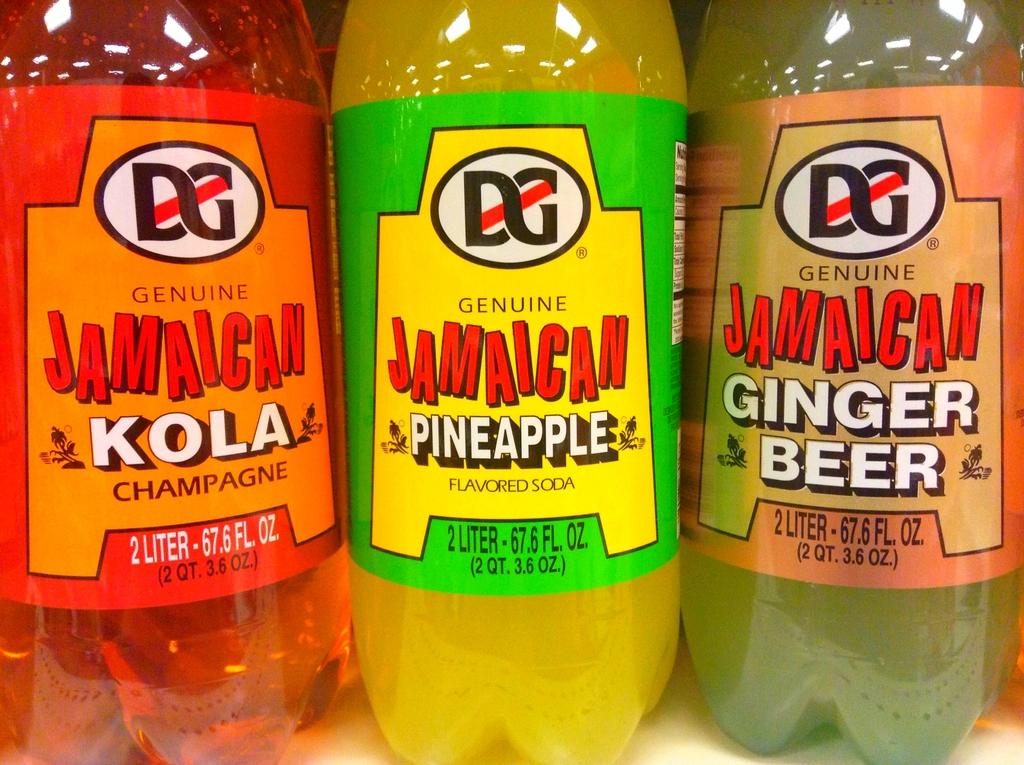<image>
Summarize the visual content of the image. A row of Jamaican products feature pineapple, kola and ginger beer flavors. 